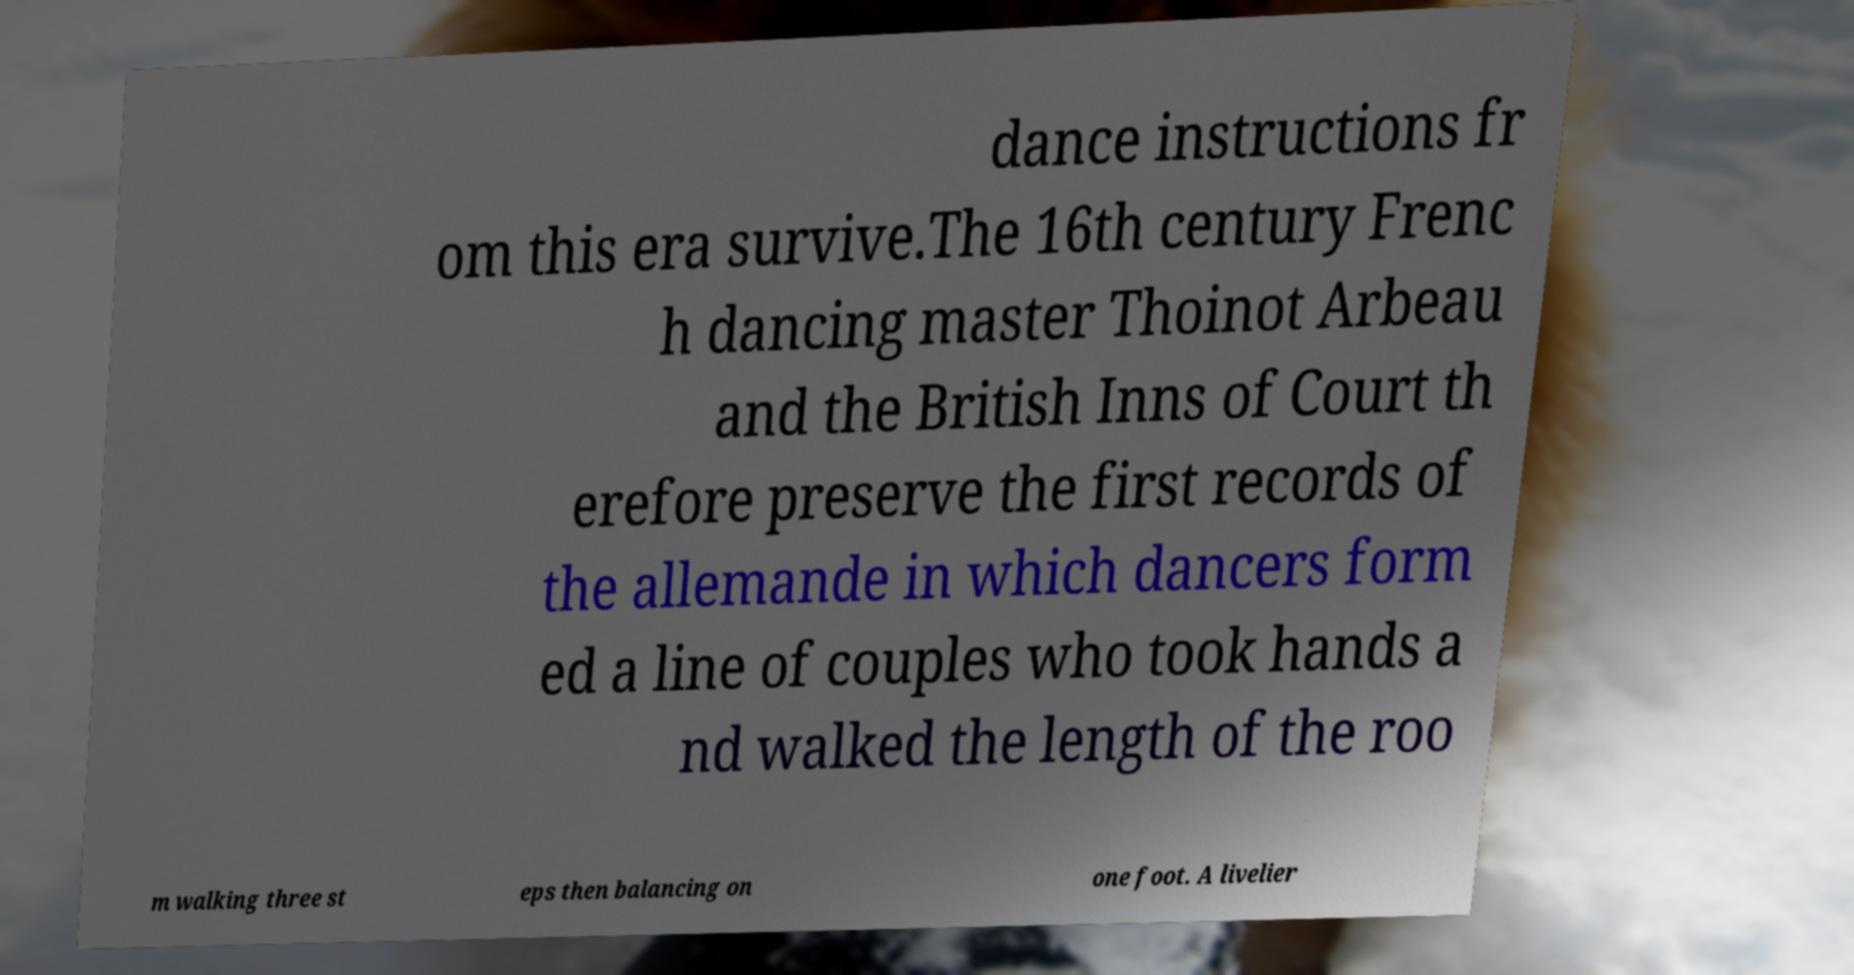Can you read and provide the text displayed in the image?This photo seems to have some interesting text. Can you extract and type it out for me? dance instructions fr om this era survive.The 16th century Frenc h dancing master Thoinot Arbeau and the British Inns of Court th erefore preserve the first records of the allemande in which dancers form ed a line of couples who took hands a nd walked the length of the roo m walking three st eps then balancing on one foot. A livelier 